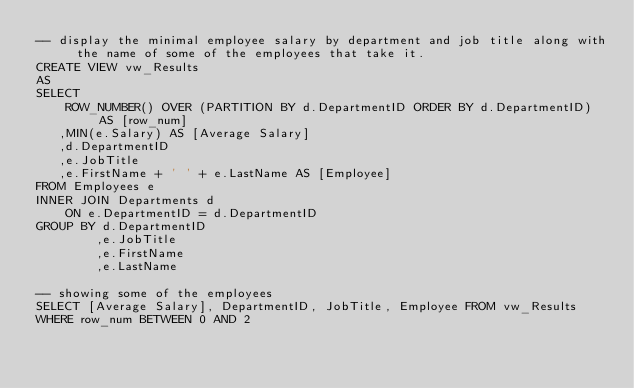<code> <loc_0><loc_0><loc_500><loc_500><_SQL_>-- display the minimal employee salary by department and job title along with the name of some of the employees that take it.
CREATE VIEW vw_Results
AS
SELECT
	ROW_NUMBER() OVER (PARTITION BY d.DepartmentID ORDER BY d.DepartmentID) AS [row_num]
   ,MIN(e.Salary) AS [Average Salary]
   ,d.DepartmentID
   ,e.JobTitle
   ,e.FirstName + ' ' + e.LastName AS [Employee]
FROM Employees e
INNER JOIN Departments d
	ON e.DepartmentID = d.DepartmentID
GROUP BY d.DepartmentID
		,e.JobTitle
		,e.FirstName
		,e.LastName

-- showing some of the employees
SELECT [Average Salary], DepartmentID, JobTitle, Employee FROM vw_Results
WHERE row_num BETWEEN 0 AND 2

</code> 